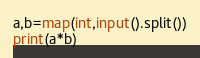<code> <loc_0><loc_0><loc_500><loc_500><_Python_>a,b=map(int,input().split())
print(a*b)
</code> 